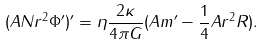Convert formula to latex. <formula><loc_0><loc_0><loc_500><loc_500>( A N r ^ { 2 } \Phi ^ { \prime } ) ^ { \prime } = \eta \frac { 2 \kappa } { 4 \pi G } ( A m ^ { \prime } - \frac { 1 } { 4 } A r ^ { 2 } R ) .</formula> 